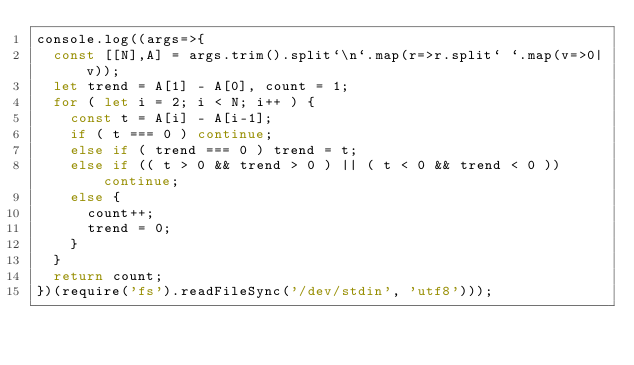<code> <loc_0><loc_0><loc_500><loc_500><_JavaScript_>console.log((args=>{
  const [[N],A] = args.trim().split`\n`.map(r=>r.split` `.map(v=>0|v));
  let trend = A[1] - A[0], count = 1;
  for ( let i = 2; i < N; i++ ) {
    const t = A[i] - A[i-1];
    if ( t === 0 ) continue;
    else if ( trend === 0 ) trend = t;
    else if (( t > 0 && trend > 0 ) || ( t < 0 && trend < 0 )) continue;
    else {
      count++;
      trend = 0;
    }
  }
  return count;
})(require('fs').readFileSync('/dev/stdin', 'utf8')));
</code> 